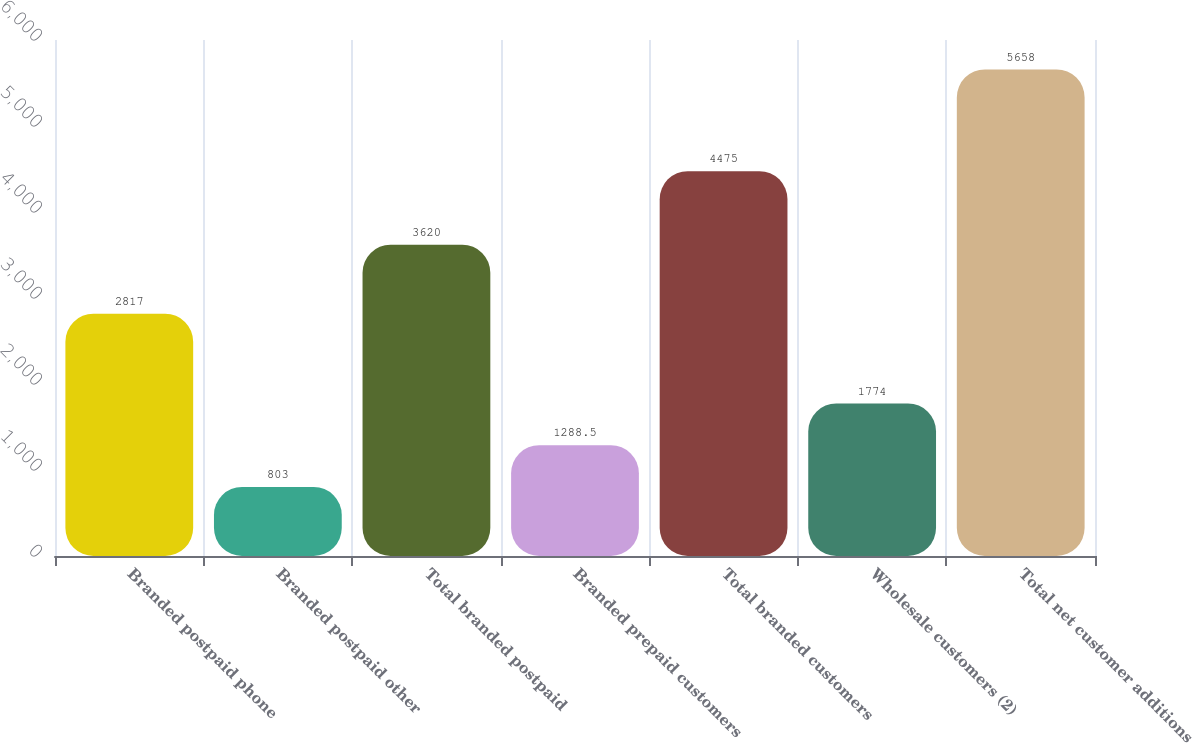Convert chart to OTSL. <chart><loc_0><loc_0><loc_500><loc_500><bar_chart><fcel>Branded postpaid phone<fcel>Branded postpaid other<fcel>Total branded postpaid<fcel>Branded prepaid customers<fcel>Total branded customers<fcel>Wholesale customers (2)<fcel>Total net customer additions<nl><fcel>2817<fcel>803<fcel>3620<fcel>1288.5<fcel>4475<fcel>1774<fcel>5658<nl></chart> 